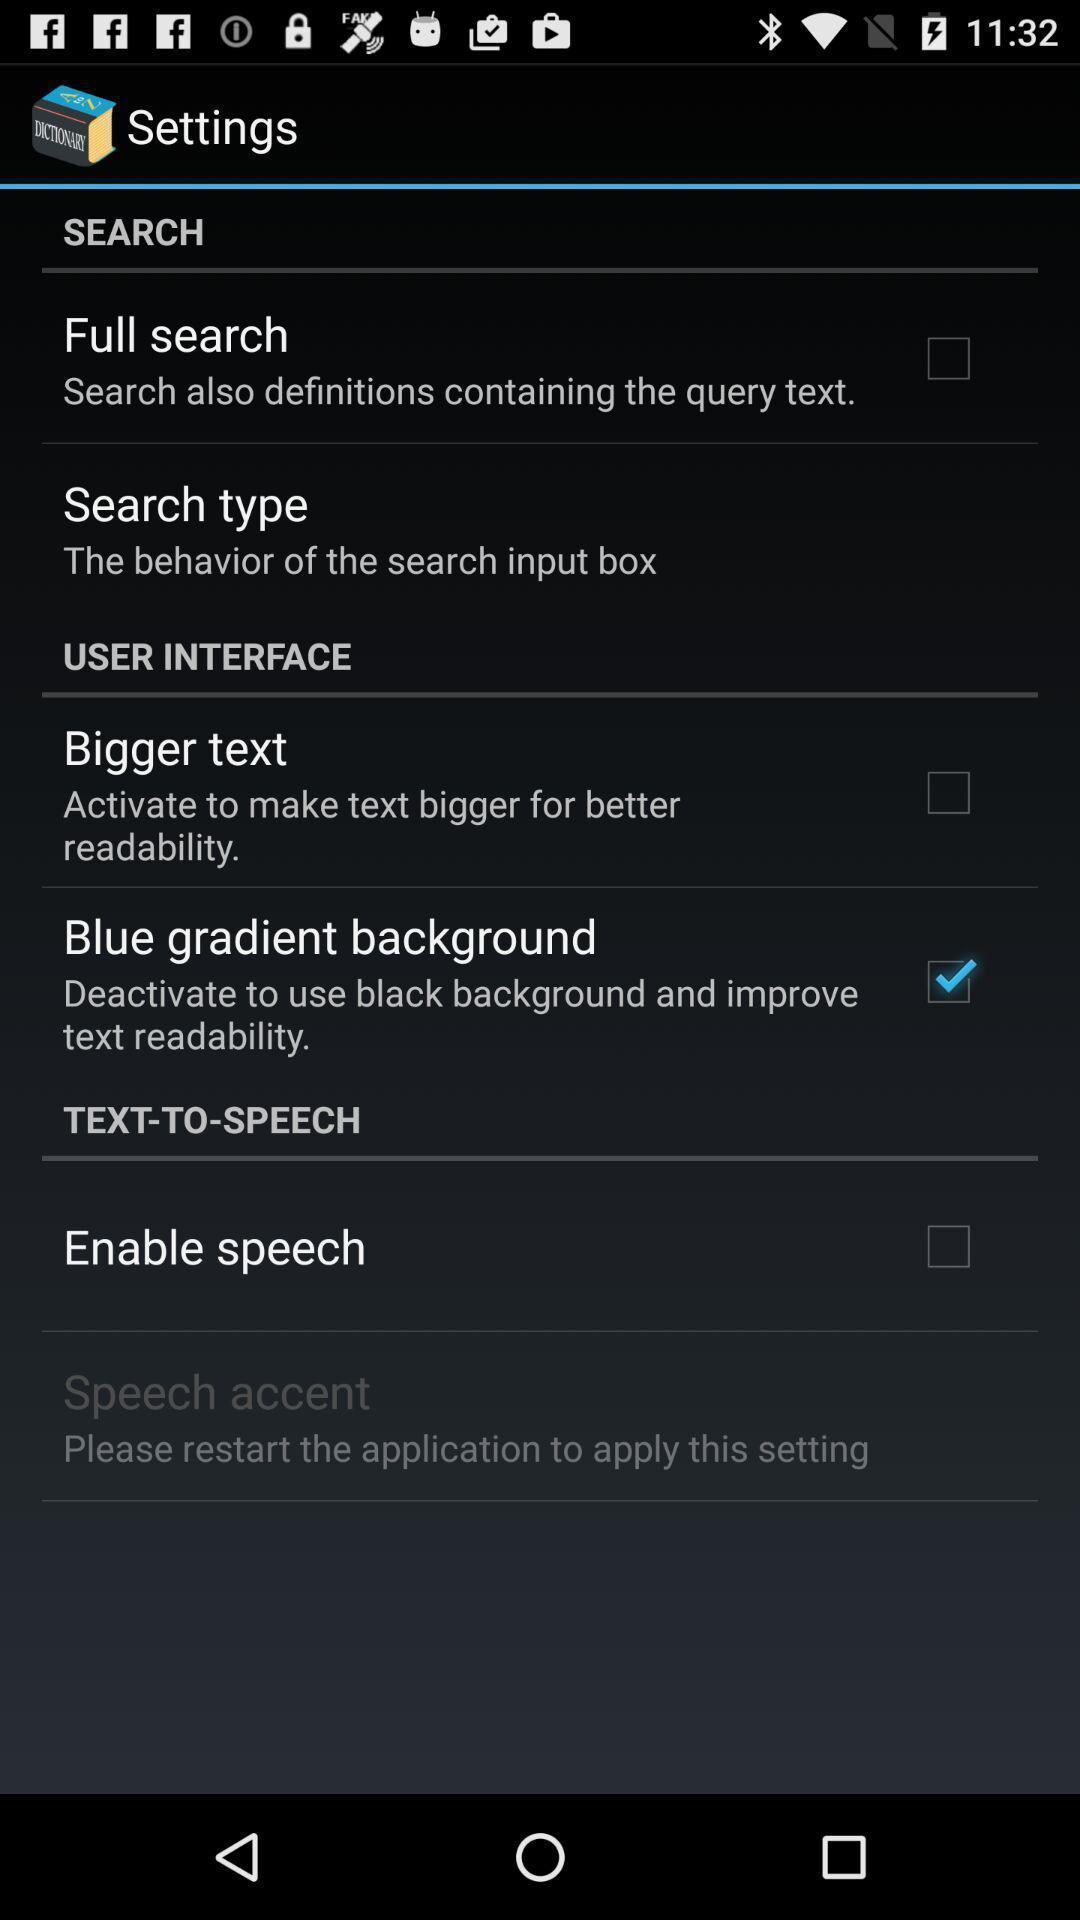Provide a detailed account of this screenshot. Settings tab with some options in mobile. 